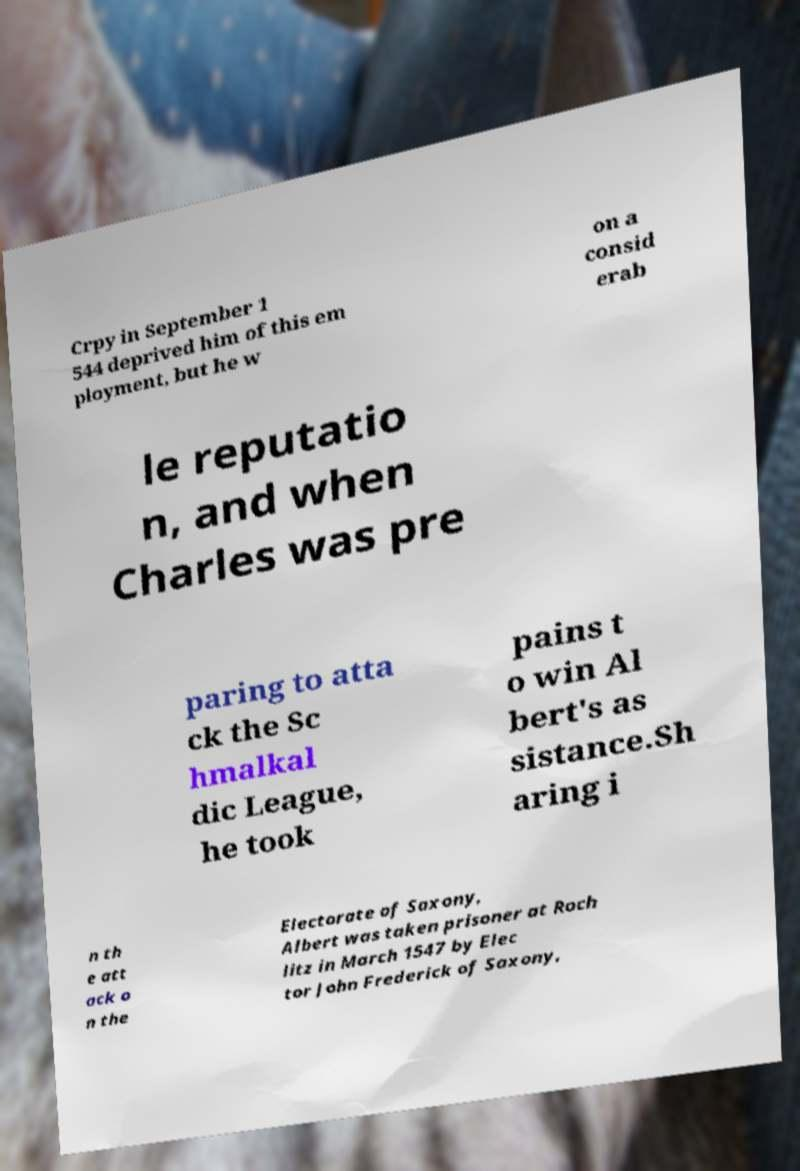Can you accurately transcribe the text from the provided image for me? Crpy in September 1 544 deprived him of this em ployment, but he w on a consid erab le reputatio n, and when Charles was pre paring to atta ck the Sc hmalkal dic League, he took pains t o win Al bert's as sistance.Sh aring i n th e att ack o n the Electorate of Saxony, Albert was taken prisoner at Roch litz in March 1547 by Elec tor John Frederick of Saxony, 